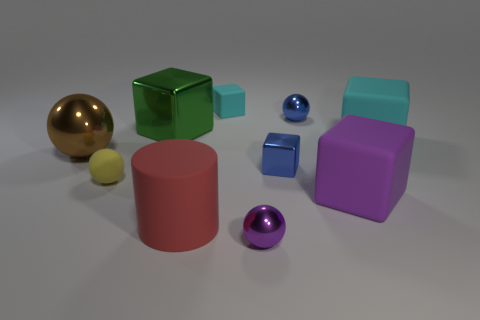There is a cyan rubber object that is on the right side of the tiny metal cube; what is its size?
Ensure brevity in your answer.  Large. What shape is the small purple shiny object?
Keep it short and to the point. Sphere. There is a sphere behind the brown metal ball; is its size the same as the ball that is to the left of the yellow rubber thing?
Provide a short and direct response. No. There is a shiny cube that is right of the big matte thing that is on the left side of the object in front of the red matte cylinder; how big is it?
Your answer should be very brief. Small. What is the shape of the cyan thing that is behind the cyan object to the right of the blue metal thing that is on the left side of the blue metallic sphere?
Give a very brief answer. Cube. What shape is the tiny matte object on the right side of the matte cylinder?
Ensure brevity in your answer.  Cube. Is the small purple object made of the same material as the cyan thing that is behind the big green thing?
Your response must be concise. No. How many other objects are the same shape as the large red object?
Your response must be concise. 0. Is the color of the small metallic block the same as the tiny metal thing that is behind the large brown thing?
Offer a terse response. Yes. What is the shape of the metallic object behind the metal cube left of the small blue metallic block?
Your response must be concise. Sphere. 